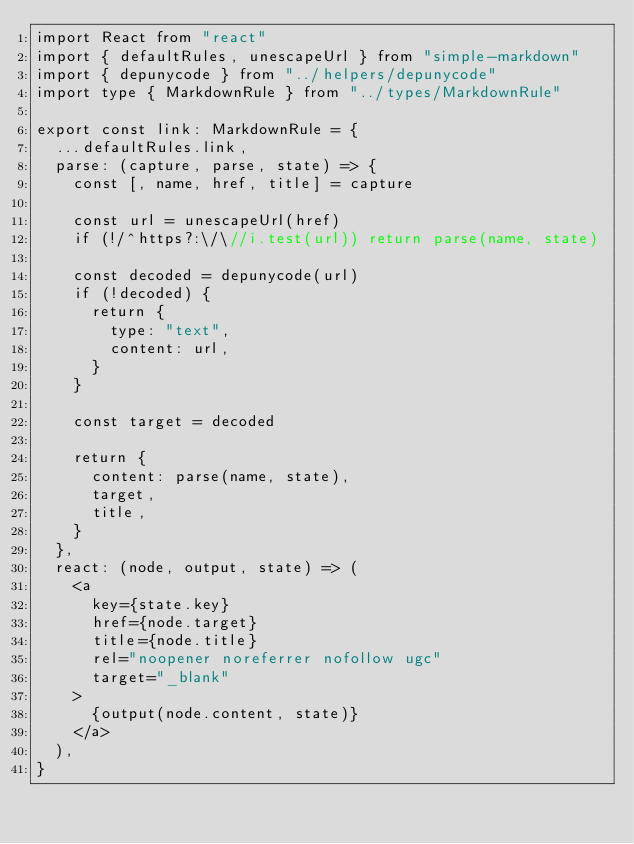<code> <loc_0><loc_0><loc_500><loc_500><_TypeScript_>import React from "react"
import { defaultRules, unescapeUrl } from "simple-markdown"
import { depunycode } from "../helpers/depunycode"
import type { MarkdownRule } from "../types/MarkdownRule"

export const link: MarkdownRule = {
  ...defaultRules.link,
  parse: (capture, parse, state) => {
    const [, name, href, title] = capture

    const url = unescapeUrl(href)
    if (!/^https?:\/\//i.test(url)) return parse(name, state)

    const decoded = depunycode(url)
    if (!decoded) {
      return {
        type: "text",
        content: url,
      }
    }

    const target = decoded

    return {
      content: parse(name, state),
      target,
      title,
    }
  },
  react: (node, output, state) => (
    <a
      key={state.key}
      href={node.target}
      title={node.title}
      rel="noopener noreferrer nofollow ugc"
      target="_blank"
    >
      {output(node.content, state)}
    </a>
  ),
}
</code> 